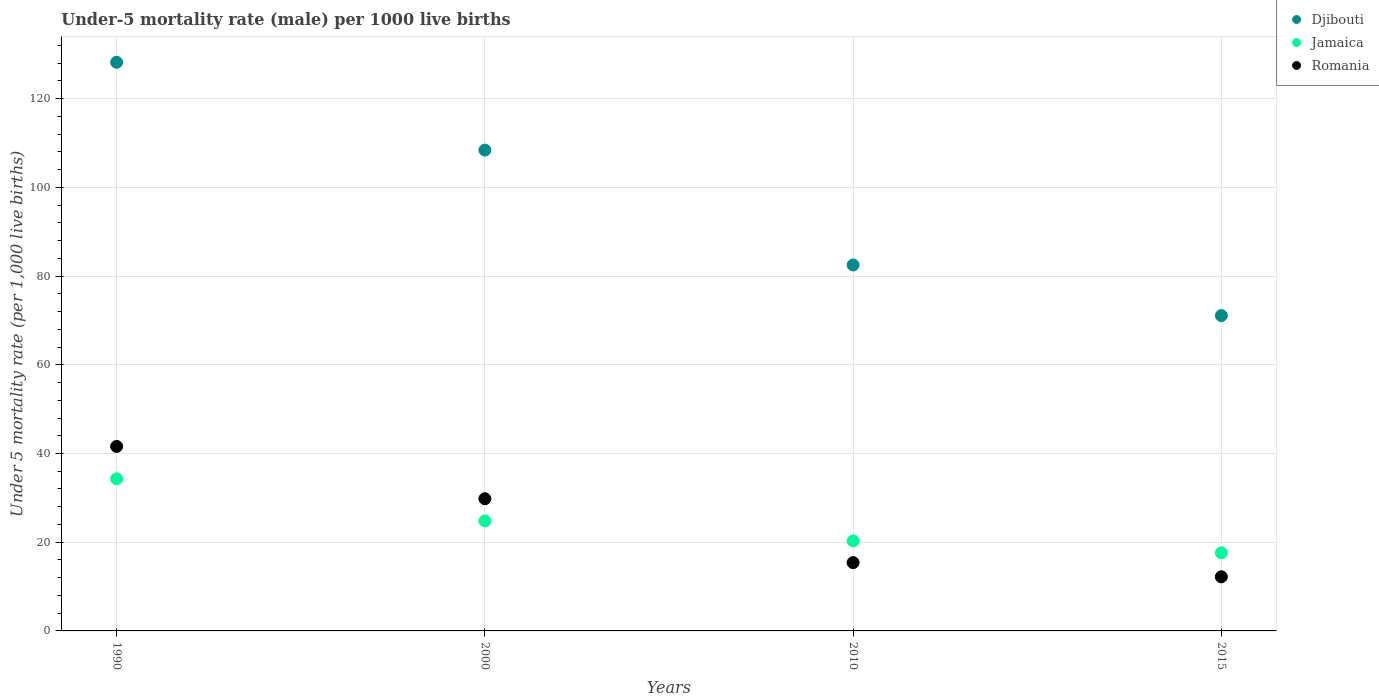Is the number of dotlines equal to the number of legend labels?
Give a very brief answer. Yes. What is the under-five mortality rate in Jamaica in 2015?
Your response must be concise. 17.6. Across all years, what is the maximum under-five mortality rate in Jamaica?
Provide a short and direct response. 34.3. Across all years, what is the minimum under-five mortality rate in Djibouti?
Your answer should be compact. 71.1. In which year was the under-five mortality rate in Romania maximum?
Your answer should be very brief. 1990. In which year was the under-five mortality rate in Jamaica minimum?
Keep it short and to the point. 2015. What is the total under-five mortality rate in Romania in the graph?
Provide a succinct answer. 99. What is the difference between the under-five mortality rate in Djibouti in 1990 and that in 2010?
Your response must be concise. 45.7. What is the difference between the under-five mortality rate in Djibouti in 1990 and the under-five mortality rate in Jamaica in 2010?
Keep it short and to the point. 107.9. What is the average under-five mortality rate in Djibouti per year?
Your response must be concise. 97.55. In the year 2015, what is the difference between the under-five mortality rate in Djibouti and under-five mortality rate in Romania?
Keep it short and to the point. 58.9. What is the ratio of the under-five mortality rate in Djibouti in 2000 to that in 2015?
Provide a short and direct response. 1.52. Is the under-five mortality rate in Romania in 1990 less than that in 2010?
Provide a short and direct response. No. What is the difference between the highest and the second highest under-five mortality rate in Jamaica?
Your answer should be very brief. 9.5. What is the difference between the highest and the lowest under-five mortality rate in Jamaica?
Your response must be concise. 16.7. In how many years, is the under-five mortality rate in Djibouti greater than the average under-five mortality rate in Djibouti taken over all years?
Provide a short and direct response. 2. Is the under-five mortality rate in Djibouti strictly greater than the under-five mortality rate in Romania over the years?
Make the answer very short. Yes. How many dotlines are there?
Ensure brevity in your answer.  3. Are the values on the major ticks of Y-axis written in scientific E-notation?
Provide a succinct answer. No. Does the graph contain any zero values?
Your answer should be compact. No. Does the graph contain grids?
Your answer should be very brief. Yes. How many legend labels are there?
Offer a very short reply. 3. What is the title of the graph?
Offer a very short reply. Under-5 mortality rate (male) per 1000 live births. Does "Turks and Caicos Islands" appear as one of the legend labels in the graph?
Provide a short and direct response. No. What is the label or title of the X-axis?
Provide a short and direct response. Years. What is the label or title of the Y-axis?
Your answer should be very brief. Under 5 mortality rate (per 1,0 live births). What is the Under 5 mortality rate (per 1,000 live births) in Djibouti in 1990?
Provide a short and direct response. 128.2. What is the Under 5 mortality rate (per 1,000 live births) of Jamaica in 1990?
Make the answer very short. 34.3. What is the Under 5 mortality rate (per 1,000 live births) in Romania in 1990?
Keep it short and to the point. 41.6. What is the Under 5 mortality rate (per 1,000 live births) in Djibouti in 2000?
Provide a short and direct response. 108.4. What is the Under 5 mortality rate (per 1,000 live births) in Jamaica in 2000?
Ensure brevity in your answer.  24.8. What is the Under 5 mortality rate (per 1,000 live births) in Romania in 2000?
Provide a short and direct response. 29.8. What is the Under 5 mortality rate (per 1,000 live births) of Djibouti in 2010?
Your answer should be compact. 82.5. What is the Under 5 mortality rate (per 1,000 live births) in Jamaica in 2010?
Give a very brief answer. 20.3. What is the Under 5 mortality rate (per 1,000 live births) of Djibouti in 2015?
Offer a terse response. 71.1. Across all years, what is the maximum Under 5 mortality rate (per 1,000 live births) of Djibouti?
Offer a very short reply. 128.2. Across all years, what is the maximum Under 5 mortality rate (per 1,000 live births) of Jamaica?
Offer a very short reply. 34.3. Across all years, what is the maximum Under 5 mortality rate (per 1,000 live births) in Romania?
Make the answer very short. 41.6. Across all years, what is the minimum Under 5 mortality rate (per 1,000 live births) in Djibouti?
Your response must be concise. 71.1. What is the total Under 5 mortality rate (per 1,000 live births) of Djibouti in the graph?
Provide a succinct answer. 390.2. What is the total Under 5 mortality rate (per 1,000 live births) of Jamaica in the graph?
Give a very brief answer. 97. What is the total Under 5 mortality rate (per 1,000 live births) in Romania in the graph?
Make the answer very short. 99. What is the difference between the Under 5 mortality rate (per 1,000 live births) of Djibouti in 1990 and that in 2000?
Your response must be concise. 19.8. What is the difference between the Under 5 mortality rate (per 1,000 live births) of Romania in 1990 and that in 2000?
Keep it short and to the point. 11.8. What is the difference between the Under 5 mortality rate (per 1,000 live births) in Djibouti in 1990 and that in 2010?
Provide a short and direct response. 45.7. What is the difference between the Under 5 mortality rate (per 1,000 live births) of Jamaica in 1990 and that in 2010?
Your response must be concise. 14. What is the difference between the Under 5 mortality rate (per 1,000 live births) in Romania in 1990 and that in 2010?
Offer a very short reply. 26.2. What is the difference between the Under 5 mortality rate (per 1,000 live births) of Djibouti in 1990 and that in 2015?
Your answer should be compact. 57.1. What is the difference between the Under 5 mortality rate (per 1,000 live births) of Romania in 1990 and that in 2015?
Make the answer very short. 29.4. What is the difference between the Under 5 mortality rate (per 1,000 live births) of Djibouti in 2000 and that in 2010?
Provide a short and direct response. 25.9. What is the difference between the Under 5 mortality rate (per 1,000 live births) in Romania in 2000 and that in 2010?
Keep it short and to the point. 14.4. What is the difference between the Under 5 mortality rate (per 1,000 live births) in Djibouti in 2000 and that in 2015?
Your answer should be very brief. 37.3. What is the difference between the Under 5 mortality rate (per 1,000 live births) in Jamaica in 2000 and that in 2015?
Offer a terse response. 7.2. What is the difference between the Under 5 mortality rate (per 1,000 live births) in Romania in 2000 and that in 2015?
Your answer should be very brief. 17.6. What is the difference between the Under 5 mortality rate (per 1,000 live births) in Djibouti in 2010 and that in 2015?
Give a very brief answer. 11.4. What is the difference between the Under 5 mortality rate (per 1,000 live births) in Djibouti in 1990 and the Under 5 mortality rate (per 1,000 live births) in Jamaica in 2000?
Keep it short and to the point. 103.4. What is the difference between the Under 5 mortality rate (per 1,000 live births) of Djibouti in 1990 and the Under 5 mortality rate (per 1,000 live births) of Romania in 2000?
Give a very brief answer. 98.4. What is the difference between the Under 5 mortality rate (per 1,000 live births) in Jamaica in 1990 and the Under 5 mortality rate (per 1,000 live births) in Romania in 2000?
Your response must be concise. 4.5. What is the difference between the Under 5 mortality rate (per 1,000 live births) in Djibouti in 1990 and the Under 5 mortality rate (per 1,000 live births) in Jamaica in 2010?
Make the answer very short. 107.9. What is the difference between the Under 5 mortality rate (per 1,000 live births) of Djibouti in 1990 and the Under 5 mortality rate (per 1,000 live births) of Romania in 2010?
Offer a terse response. 112.8. What is the difference between the Under 5 mortality rate (per 1,000 live births) in Jamaica in 1990 and the Under 5 mortality rate (per 1,000 live births) in Romania in 2010?
Provide a short and direct response. 18.9. What is the difference between the Under 5 mortality rate (per 1,000 live births) of Djibouti in 1990 and the Under 5 mortality rate (per 1,000 live births) of Jamaica in 2015?
Ensure brevity in your answer.  110.6. What is the difference between the Under 5 mortality rate (per 1,000 live births) of Djibouti in 1990 and the Under 5 mortality rate (per 1,000 live births) of Romania in 2015?
Provide a short and direct response. 116. What is the difference between the Under 5 mortality rate (per 1,000 live births) of Jamaica in 1990 and the Under 5 mortality rate (per 1,000 live births) of Romania in 2015?
Offer a very short reply. 22.1. What is the difference between the Under 5 mortality rate (per 1,000 live births) of Djibouti in 2000 and the Under 5 mortality rate (per 1,000 live births) of Jamaica in 2010?
Ensure brevity in your answer.  88.1. What is the difference between the Under 5 mortality rate (per 1,000 live births) in Djibouti in 2000 and the Under 5 mortality rate (per 1,000 live births) in Romania in 2010?
Provide a succinct answer. 93. What is the difference between the Under 5 mortality rate (per 1,000 live births) in Djibouti in 2000 and the Under 5 mortality rate (per 1,000 live births) in Jamaica in 2015?
Ensure brevity in your answer.  90.8. What is the difference between the Under 5 mortality rate (per 1,000 live births) in Djibouti in 2000 and the Under 5 mortality rate (per 1,000 live births) in Romania in 2015?
Ensure brevity in your answer.  96.2. What is the difference between the Under 5 mortality rate (per 1,000 live births) in Jamaica in 2000 and the Under 5 mortality rate (per 1,000 live births) in Romania in 2015?
Provide a succinct answer. 12.6. What is the difference between the Under 5 mortality rate (per 1,000 live births) of Djibouti in 2010 and the Under 5 mortality rate (per 1,000 live births) of Jamaica in 2015?
Your answer should be very brief. 64.9. What is the difference between the Under 5 mortality rate (per 1,000 live births) in Djibouti in 2010 and the Under 5 mortality rate (per 1,000 live births) in Romania in 2015?
Offer a terse response. 70.3. What is the difference between the Under 5 mortality rate (per 1,000 live births) of Jamaica in 2010 and the Under 5 mortality rate (per 1,000 live births) of Romania in 2015?
Give a very brief answer. 8.1. What is the average Under 5 mortality rate (per 1,000 live births) of Djibouti per year?
Ensure brevity in your answer.  97.55. What is the average Under 5 mortality rate (per 1,000 live births) of Jamaica per year?
Provide a succinct answer. 24.25. What is the average Under 5 mortality rate (per 1,000 live births) of Romania per year?
Make the answer very short. 24.75. In the year 1990, what is the difference between the Under 5 mortality rate (per 1,000 live births) of Djibouti and Under 5 mortality rate (per 1,000 live births) of Jamaica?
Give a very brief answer. 93.9. In the year 1990, what is the difference between the Under 5 mortality rate (per 1,000 live births) of Djibouti and Under 5 mortality rate (per 1,000 live births) of Romania?
Make the answer very short. 86.6. In the year 2000, what is the difference between the Under 5 mortality rate (per 1,000 live births) of Djibouti and Under 5 mortality rate (per 1,000 live births) of Jamaica?
Provide a short and direct response. 83.6. In the year 2000, what is the difference between the Under 5 mortality rate (per 1,000 live births) in Djibouti and Under 5 mortality rate (per 1,000 live births) in Romania?
Offer a terse response. 78.6. In the year 2010, what is the difference between the Under 5 mortality rate (per 1,000 live births) of Djibouti and Under 5 mortality rate (per 1,000 live births) of Jamaica?
Offer a very short reply. 62.2. In the year 2010, what is the difference between the Under 5 mortality rate (per 1,000 live births) of Djibouti and Under 5 mortality rate (per 1,000 live births) of Romania?
Offer a terse response. 67.1. In the year 2010, what is the difference between the Under 5 mortality rate (per 1,000 live births) in Jamaica and Under 5 mortality rate (per 1,000 live births) in Romania?
Your response must be concise. 4.9. In the year 2015, what is the difference between the Under 5 mortality rate (per 1,000 live births) in Djibouti and Under 5 mortality rate (per 1,000 live births) in Jamaica?
Your answer should be very brief. 53.5. In the year 2015, what is the difference between the Under 5 mortality rate (per 1,000 live births) of Djibouti and Under 5 mortality rate (per 1,000 live births) of Romania?
Give a very brief answer. 58.9. What is the ratio of the Under 5 mortality rate (per 1,000 live births) in Djibouti in 1990 to that in 2000?
Offer a very short reply. 1.18. What is the ratio of the Under 5 mortality rate (per 1,000 live births) in Jamaica in 1990 to that in 2000?
Provide a short and direct response. 1.38. What is the ratio of the Under 5 mortality rate (per 1,000 live births) of Romania in 1990 to that in 2000?
Ensure brevity in your answer.  1.4. What is the ratio of the Under 5 mortality rate (per 1,000 live births) in Djibouti in 1990 to that in 2010?
Your response must be concise. 1.55. What is the ratio of the Under 5 mortality rate (per 1,000 live births) of Jamaica in 1990 to that in 2010?
Your answer should be compact. 1.69. What is the ratio of the Under 5 mortality rate (per 1,000 live births) in Romania in 1990 to that in 2010?
Offer a terse response. 2.7. What is the ratio of the Under 5 mortality rate (per 1,000 live births) of Djibouti in 1990 to that in 2015?
Offer a terse response. 1.8. What is the ratio of the Under 5 mortality rate (per 1,000 live births) in Jamaica in 1990 to that in 2015?
Offer a terse response. 1.95. What is the ratio of the Under 5 mortality rate (per 1,000 live births) in Romania in 1990 to that in 2015?
Your response must be concise. 3.41. What is the ratio of the Under 5 mortality rate (per 1,000 live births) in Djibouti in 2000 to that in 2010?
Make the answer very short. 1.31. What is the ratio of the Under 5 mortality rate (per 1,000 live births) of Jamaica in 2000 to that in 2010?
Offer a terse response. 1.22. What is the ratio of the Under 5 mortality rate (per 1,000 live births) of Romania in 2000 to that in 2010?
Make the answer very short. 1.94. What is the ratio of the Under 5 mortality rate (per 1,000 live births) in Djibouti in 2000 to that in 2015?
Give a very brief answer. 1.52. What is the ratio of the Under 5 mortality rate (per 1,000 live births) in Jamaica in 2000 to that in 2015?
Provide a succinct answer. 1.41. What is the ratio of the Under 5 mortality rate (per 1,000 live births) in Romania in 2000 to that in 2015?
Your answer should be very brief. 2.44. What is the ratio of the Under 5 mortality rate (per 1,000 live births) of Djibouti in 2010 to that in 2015?
Your response must be concise. 1.16. What is the ratio of the Under 5 mortality rate (per 1,000 live births) of Jamaica in 2010 to that in 2015?
Your answer should be very brief. 1.15. What is the ratio of the Under 5 mortality rate (per 1,000 live births) of Romania in 2010 to that in 2015?
Offer a terse response. 1.26. What is the difference between the highest and the second highest Under 5 mortality rate (per 1,000 live births) in Djibouti?
Your response must be concise. 19.8. What is the difference between the highest and the second highest Under 5 mortality rate (per 1,000 live births) of Jamaica?
Your answer should be very brief. 9.5. What is the difference between the highest and the second highest Under 5 mortality rate (per 1,000 live births) of Romania?
Make the answer very short. 11.8. What is the difference between the highest and the lowest Under 5 mortality rate (per 1,000 live births) in Djibouti?
Keep it short and to the point. 57.1. What is the difference between the highest and the lowest Under 5 mortality rate (per 1,000 live births) in Romania?
Give a very brief answer. 29.4. 